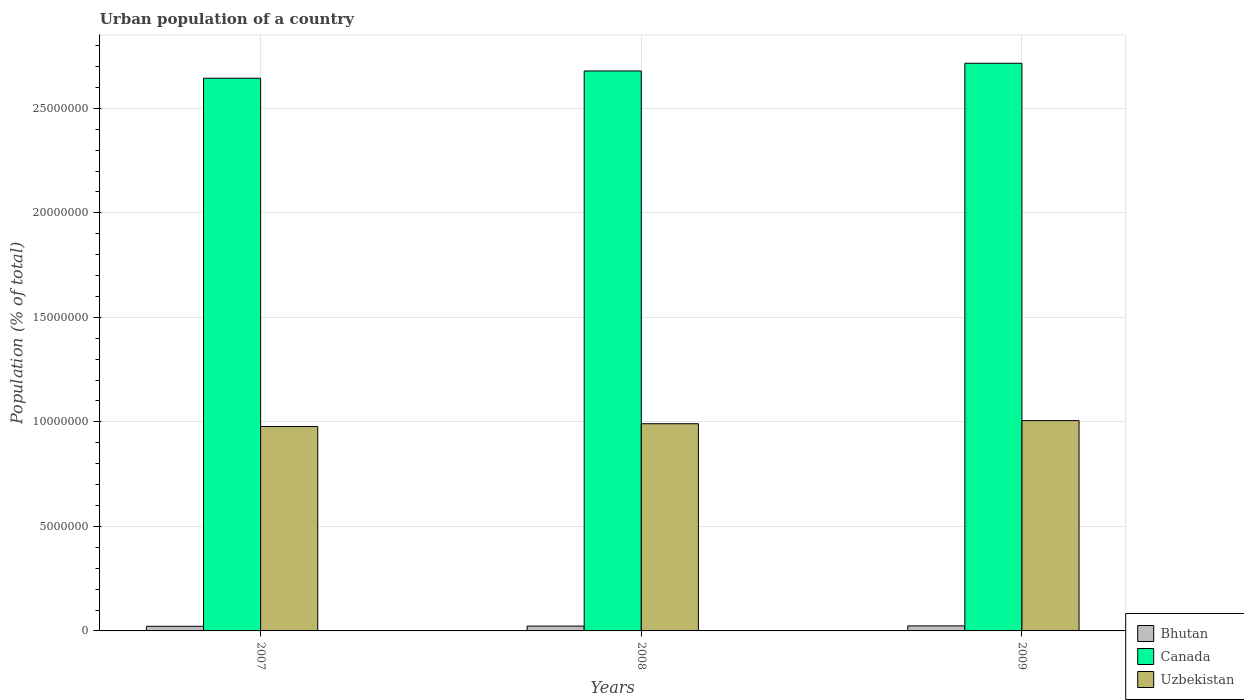Are the number of bars per tick equal to the number of legend labels?
Provide a short and direct response. Yes. In how many cases, is the number of bars for a given year not equal to the number of legend labels?
Your response must be concise. 0. What is the urban population in Bhutan in 2009?
Ensure brevity in your answer.  2.41e+05. Across all years, what is the maximum urban population in Bhutan?
Your answer should be compact. 2.41e+05. Across all years, what is the minimum urban population in Uzbekistan?
Offer a very short reply. 9.78e+06. In which year was the urban population in Canada maximum?
Make the answer very short. 2009. What is the total urban population in Uzbekistan in the graph?
Offer a terse response. 2.98e+07. What is the difference between the urban population in Uzbekistan in 2007 and that in 2008?
Your response must be concise. -1.32e+05. What is the difference between the urban population in Canada in 2007 and the urban population in Bhutan in 2009?
Ensure brevity in your answer.  2.62e+07. What is the average urban population in Bhutan per year?
Your response must be concise. 2.31e+05. In the year 2009, what is the difference between the urban population in Uzbekistan and urban population in Canada?
Provide a short and direct response. -1.71e+07. What is the ratio of the urban population in Canada in 2008 to that in 2009?
Your response must be concise. 0.99. What is the difference between the highest and the second highest urban population in Uzbekistan?
Ensure brevity in your answer.  1.49e+05. What is the difference between the highest and the lowest urban population in Uzbekistan?
Your response must be concise. 2.81e+05. In how many years, is the urban population in Uzbekistan greater than the average urban population in Uzbekistan taken over all years?
Your answer should be compact. 1. Is the sum of the urban population in Bhutan in 2007 and 2008 greater than the maximum urban population in Canada across all years?
Your answer should be very brief. No. What does the 3rd bar from the left in 2008 represents?
Keep it short and to the point. Uzbekistan. Is it the case that in every year, the sum of the urban population in Uzbekistan and urban population in Canada is greater than the urban population in Bhutan?
Give a very brief answer. Yes. How many years are there in the graph?
Make the answer very short. 3. Does the graph contain any zero values?
Provide a succinct answer. No. Does the graph contain grids?
Make the answer very short. Yes. How many legend labels are there?
Give a very brief answer. 3. What is the title of the graph?
Provide a short and direct response. Urban population of a country. Does "Netherlands" appear as one of the legend labels in the graph?
Offer a terse response. No. What is the label or title of the Y-axis?
Provide a succinct answer. Population (% of total). What is the Population (% of total) of Bhutan in 2007?
Your answer should be very brief. 2.21e+05. What is the Population (% of total) of Canada in 2007?
Keep it short and to the point. 2.64e+07. What is the Population (% of total) of Uzbekistan in 2007?
Your response must be concise. 9.78e+06. What is the Population (% of total) in Bhutan in 2008?
Make the answer very short. 2.31e+05. What is the Population (% of total) in Canada in 2008?
Make the answer very short. 2.68e+07. What is the Population (% of total) in Uzbekistan in 2008?
Ensure brevity in your answer.  9.91e+06. What is the Population (% of total) of Bhutan in 2009?
Keep it short and to the point. 2.41e+05. What is the Population (% of total) of Canada in 2009?
Your response must be concise. 2.72e+07. What is the Population (% of total) of Uzbekistan in 2009?
Your response must be concise. 1.01e+07. Across all years, what is the maximum Population (% of total) of Bhutan?
Your response must be concise. 2.41e+05. Across all years, what is the maximum Population (% of total) of Canada?
Provide a succinct answer. 2.72e+07. Across all years, what is the maximum Population (% of total) in Uzbekistan?
Keep it short and to the point. 1.01e+07. Across all years, what is the minimum Population (% of total) of Bhutan?
Give a very brief answer. 2.21e+05. Across all years, what is the minimum Population (% of total) of Canada?
Give a very brief answer. 2.64e+07. Across all years, what is the minimum Population (% of total) of Uzbekistan?
Keep it short and to the point. 9.78e+06. What is the total Population (% of total) in Bhutan in the graph?
Ensure brevity in your answer.  6.93e+05. What is the total Population (% of total) of Canada in the graph?
Ensure brevity in your answer.  8.04e+07. What is the total Population (% of total) of Uzbekistan in the graph?
Make the answer very short. 2.98e+07. What is the difference between the Population (% of total) in Bhutan in 2007 and that in 2008?
Your answer should be very brief. -9720. What is the difference between the Population (% of total) of Canada in 2007 and that in 2008?
Give a very brief answer. -3.48e+05. What is the difference between the Population (% of total) in Uzbekistan in 2007 and that in 2008?
Your answer should be very brief. -1.32e+05. What is the difference between the Population (% of total) of Bhutan in 2007 and that in 2009?
Your answer should be very brief. -1.95e+04. What is the difference between the Population (% of total) of Canada in 2007 and that in 2009?
Provide a succinct answer. -7.17e+05. What is the difference between the Population (% of total) in Uzbekistan in 2007 and that in 2009?
Ensure brevity in your answer.  -2.81e+05. What is the difference between the Population (% of total) of Bhutan in 2008 and that in 2009?
Ensure brevity in your answer.  -9746. What is the difference between the Population (% of total) in Canada in 2008 and that in 2009?
Offer a terse response. -3.69e+05. What is the difference between the Population (% of total) of Uzbekistan in 2008 and that in 2009?
Provide a succinct answer. -1.49e+05. What is the difference between the Population (% of total) in Bhutan in 2007 and the Population (% of total) in Canada in 2008?
Your answer should be very brief. -2.66e+07. What is the difference between the Population (% of total) in Bhutan in 2007 and the Population (% of total) in Uzbekistan in 2008?
Provide a short and direct response. -9.69e+06. What is the difference between the Population (% of total) of Canada in 2007 and the Population (% of total) of Uzbekistan in 2008?
Your answer should be compact. 1.65e+07. What is the difference between the Population (% of total) of Bhutan in 2007 and the Population (% of total) of Canada in 2009?
Give a very brief answer. -2.69e+07. What is the difference between the Population (% of total) of Bhutan in 2007 and the Population (% of total) of Uzbekistan in 2009?
Your answer should be compact. -9.84e+06. What is the difference between the Population (% of total) of Canada in 2007 and the Population (% of total) of Uzbekistan in 2009?
Make the answer very short. 1.64e+07. What is the difference between the Population (% of total) of Bhutan in 2008 and the Population (% of total) of Canada in 2009?
Provide a succinct answer. -2.69e+07. What is the difference between the Population (% of total) of Bhutan in 2008 and the Population (% of total) of Uzbekistan in 2009?
Your response must be concise. -9.83e+06. What is the difference between the Population (% of total) in Canada in 2008 and the Population (% of total) in Uzbekistan in 2009?
Make the answer very short. 1.67e+07. What is the average Population (% of total) of Bhutan per year?
Offer a terse response. 2.31e+05. What is the average Population (% of total) in Canada per year?
Your response must be concise. 2.68e+07. What is the average Population (% of total) of Uzbekistan per year?
Offer a very short reply. 9.92e+06. In the year 2007, what is the difference between the Population (% of total) of Bhutan and Population (% of total) of Canada?
Offer a terse response. -2.62e+07. In the year 2007, what is the difference between the Population (% of total) of Bhutan and Population (% of total) of Uzbekistan?
Your response must be concise. -9.56e+06. In the year 2007, what is the difference between the Population (% of total) of Canada and Population (% of total) of Uzbekistan?
Give a very brief answer. 1.67e+07. In the year 2008, what is the difference between the Population (% of total) of Bhutan and Population (% of total) of Canada?
Your answer should be compact. -2.66e+07. In the year 2008, what is the difference between the Population (% of total) of Bhutan and Population (% of total) of Uzbekistan?
Keep it short and to the point. -9.68e+06. In the year 2008, what is the difference between the Population (% of total) in Canada and Population (% of total) in Uzbekistan?
Offer a very short reply. 1.69e+07. In the year 2009, what is the difference between the Population (% of total) in Bhutan and Population (% of total) in Canada?
Give a very brief answer. -2.69e+07. In the year 2009, what is the difference between the Population (% of total) of Bhutan and Population (% of total) of Uzbekistan?
Provide a short and direct response. -9.82e+06. In the year 2009, what is the difference between the Population (% of total) of Canada and Population (% of total) of Uzbekistan?
Give a very brief answer. 1.71e+07. What is the ratio of the Population (% of total) of Bhutan in 2007 to that in 2008?
Keep it short and to the point. 0.96. What is the ratio of the Population (% of total) of Canada in 2007 to that in 2008?
Your response must be concise. 0.99. What is the ratio of the Population (% of total) of Uzbekistan in 2007 to that in 2008?
Keep it short and to the point. 0.99. What is the ratio of the Population (% of total) in Bhutan in 2007 to that in 2009?
Provide a succinct answer. 0.92. What is the ratio of the Population (% of total) in Canada in 2007 to that in 2009?
Provide a succinct answer. 0.97. What is the ratio of the Population (% of total) in Uzbekistan in 2007 to that in 2009?
Make the answer very short. 0.97. What is the ratio of the Population (% of total) in Bhutan in 2008 to that in 2009?
Make the answer very short. 0.96. What is the ratio of the Population (% of total) of Canada in 2008 to that in 2009?
Provide a succinct answer. 0.99. What is the ratio of the Population (% of total) in Uzbekistan in 2008 to that in 2009?
Offer a terse response. 0.99. What is the difference between the highest and the second highest Population (% of total) in Bhutan?
Keep it short and to the point. 9746. What is the difference between the highest and the second highest Population (% of total) in Canada?
Give a very brief answer. 3.69e+05. What is the difference between the highest and the second highest Population (% of total) in Uzbekistan?
Keep it short and to the point. 1.49e+05. What is the difference between the highest and the lowest Population (% of total) of Bhutan?
Provide a succinct answer. 1.95e+04. What is the difference between the highest and the lowest Population (% of total) of Canada?
Your answer should be compact. 7.17e+05. What is the difference between the highest and the lowest Population (% of total) in Uzbekistan?
Keep it short and to the point. 2.81e+05. 